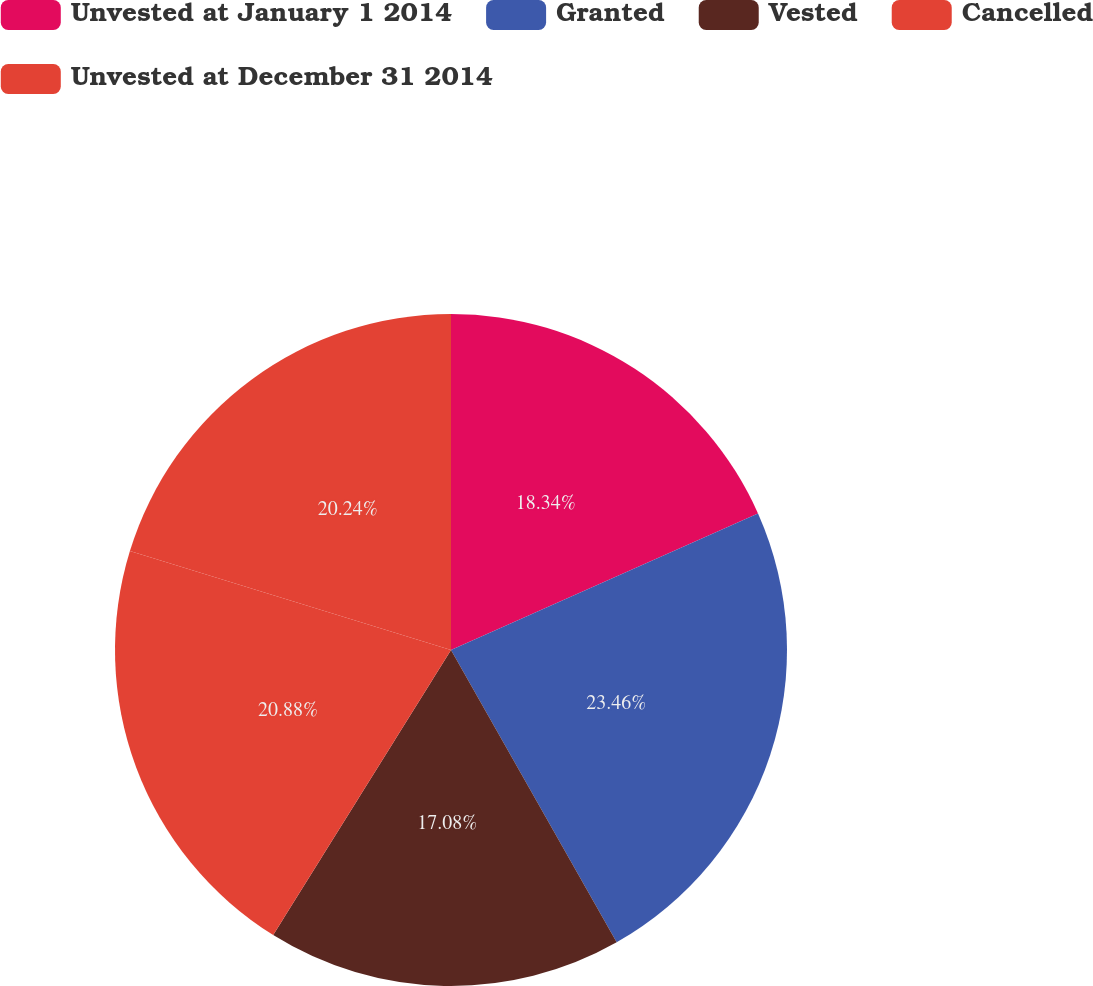<chart> <loc_0><loc_0><loc_500><loc_500><pie_chart><fcel>Unvested at January 1 2014<fcel>Granted<fcel>Vested<fcel>Cancelled<fcel>Unvested at December 31 2014<nl><fcel>18.34%<fcel>23.45%<fcel>17.08%<fcel>20.88%<fcel>20.24%<nl></chart> 